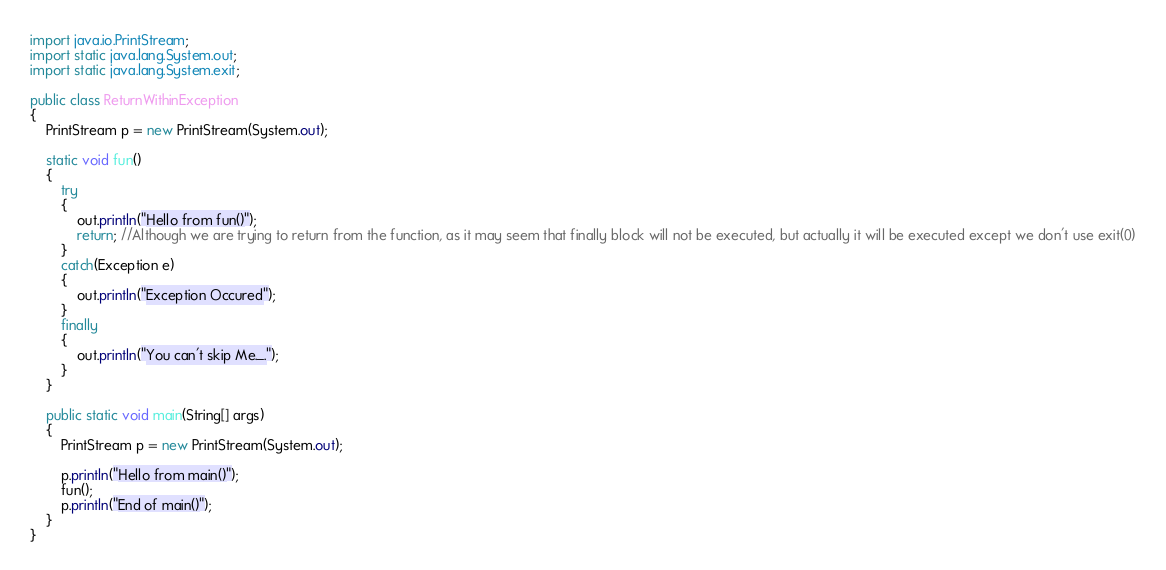Convert code to text. <code><loc_0><loc_0><loc_500><loc_500><_Java_>import java.io.PrintStream;
import static java.lang.System.out;
import static java.lang.System.exit;

public class ReturnWithinException
{
    PrintStream p = new PrintStream(System.out);

    static void fun()
    {
        try
        {
            out.println("Hello from fun()");
            return; //Although we are trying to return from the function, as it may seem that finally block will not be executed, but actually it will be executed except we don't use exit(0)
        }
        catch(Exception e)
        {
            out.println("Exception Occured");
        }
        finally
        {
            out.println("You can't skip Me._.");
        }
    }

    public static void main(String[] args)
    {
        PrintStream p = new PrintStream(System.out);

        p.println("Hello from main()");
        fun();
        p.println("End of main()");
    }
}</code> 